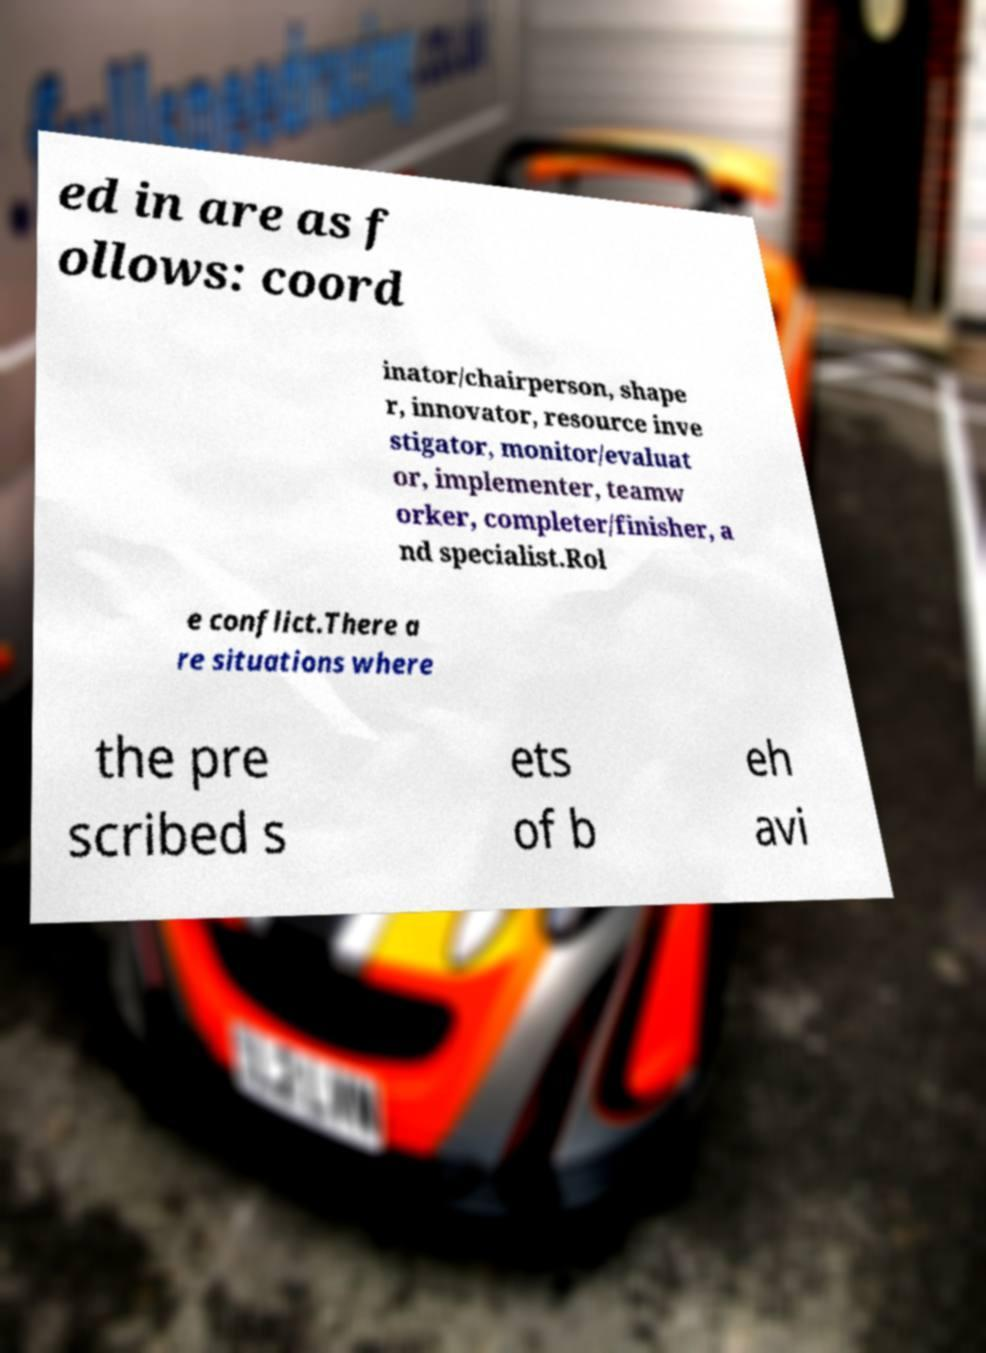Could you extract and type out the text from this image? ed in are as f ollows: coord inator/chairperson, shape r, innovator, resource inve stigator, monitor/evaluat or, implementer, teamw orker, completer/finisher, a nd specialist.Rol e conflict.There a re situations where the pre scribed s ets of b eh avi 